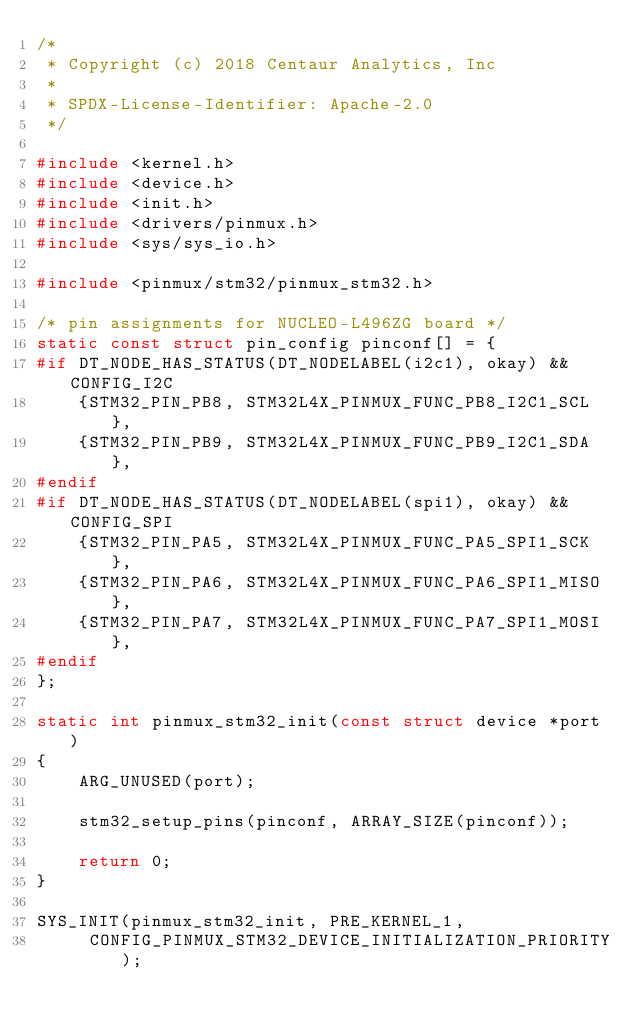<code> <loc_0><loc_0><loc_500><loc_500><_C_>/*
 * Copyright (c) 2018 Centaur Analytics, Inc
 *
 * SPDX-License-Identifier: Apache-2.0
 */

#include <kernel.h>
#include <device.h>
#include <init.h>
#include <drivers/pinmux.h>
#include <sys/sys_io.h>

#include <pinmux/stm32/pinmux_stm32.h>

/* pin assignments for NUCLEO-L496ZG board */
static const struct pin_config pinconf[] = {
#if DT_NODE_HAS_STATUS(DT_NODELABEL(i2c1), okay) && CONFIG_I2C
	{STM32_PIN_PB8, STM32L4X_PINMUX_FUNC_PB8_I2C1_SCL},
	{STM32_PIN_PB9, STM32L4X_PINMUX_FUNC_PB9_I2C1_SDA},
#endif
#if DT_NODE_HAS_STATUS(DT_NODELABEL(spi1), okay) && CONFIG_SPI
	{STM32_PIN_PA5, STM32L4X_PINMUX_FUNC_PA5_SPI1_SCK},
	{STM32_PIN_PA6, STM32L4X_PINMUX_FUNC_PA6_SPI1_MISO},
	{STM32_PIN_PA7, STM32L4X_PINMUX_FUNC_PA7_SPI1_MOSI},
#endif
};

static int pinmux_stm32_init(const struct device *port)
{
	ARG_UNUSED(port);

	stm32_setup_pins(pinconf, ARRAY_SIZE(pinconf));

	return 0;
}

SYS_INIT(pinmux_stm32_init, PRE_KERNEL_1,
	 CONFIG_PINMUX_STM32_DEVICE_INITIALIZATION_PRIORITY);
</code> 